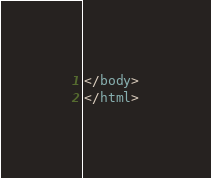Convert code to text. <code><loc_0><loc_0><loc_500><loc_500><_HTML_></body>
</html>
</code> 